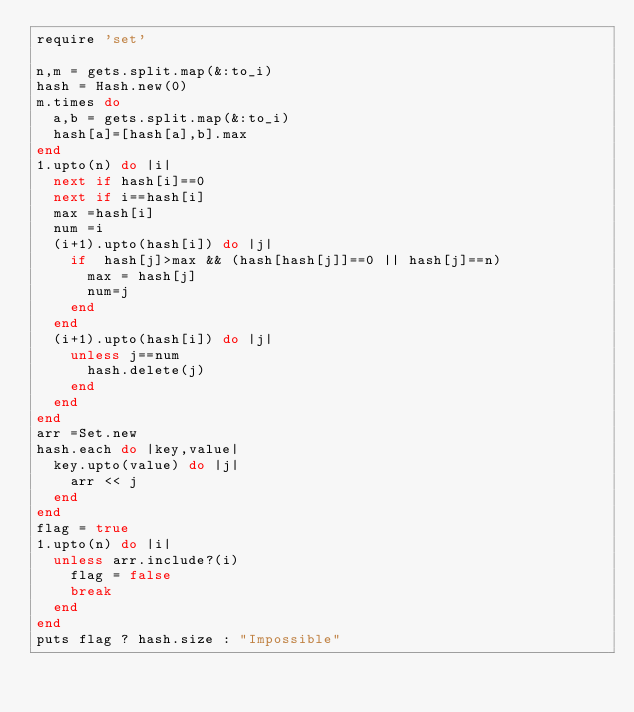<code> <loc_0><loc_0><loc_500><loc_500><_Ruby_>require 'set'

n,m = gets.split.map(&:to_i)
hash = Hash.new(0)
m.times do
  a,b = gets.split.map(&:to_i)
  hash[a]=[hash[a],b].max
end
1.upto(n) do |i|
  next if hash[i]==0
  next if i==hash[i]
  max =hash[i]
  num =i
  (i+1).upto(hash[i]) do |j|
    if  hash[j]>max && (hash[hash[j]]==0 || hash[j]==n)
      max = hash[j]
      num=j
    end
  end
  (i+1).upto(hash[i]) do |j|
    unless j==num
      hash.delete(j)
    end
  end
end
arr =Set.new
hash.each do |key,value|
  key.upto(value) do |j|
    arr << j
  end
end
flag = true
1.upto(n) do |i|
  unless arr.include?(i)
    flag = false
    break
  end
end
puts flag ? hash.size : "Impossible"</code> 